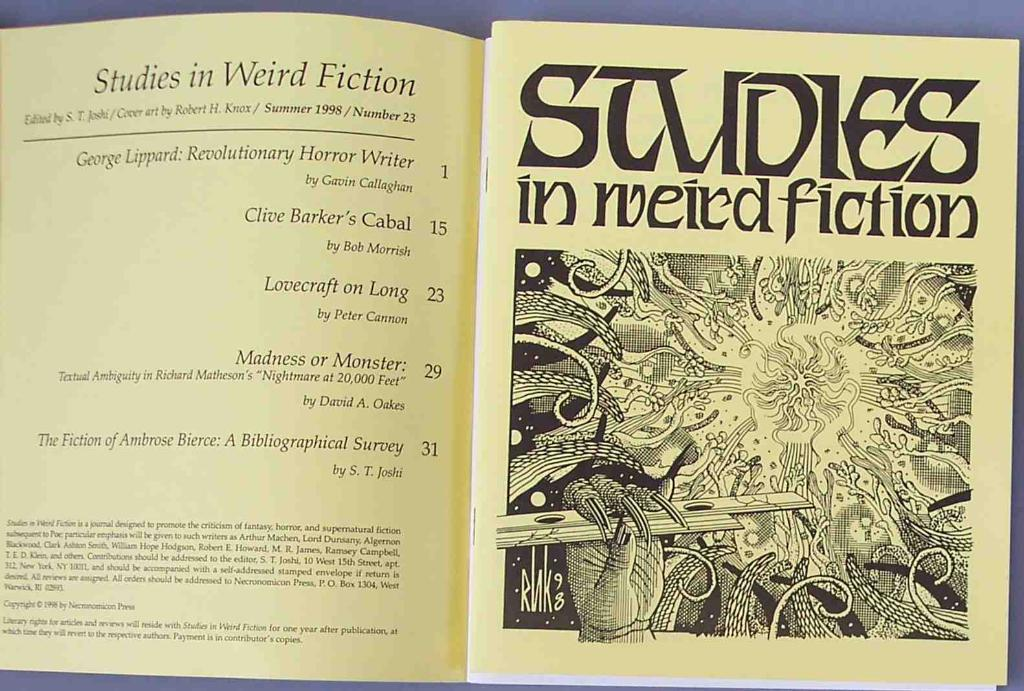Provide a one-sentence caption for the provided image. A book or pamphlet open up to the contents saying Studies in weird fiction. 